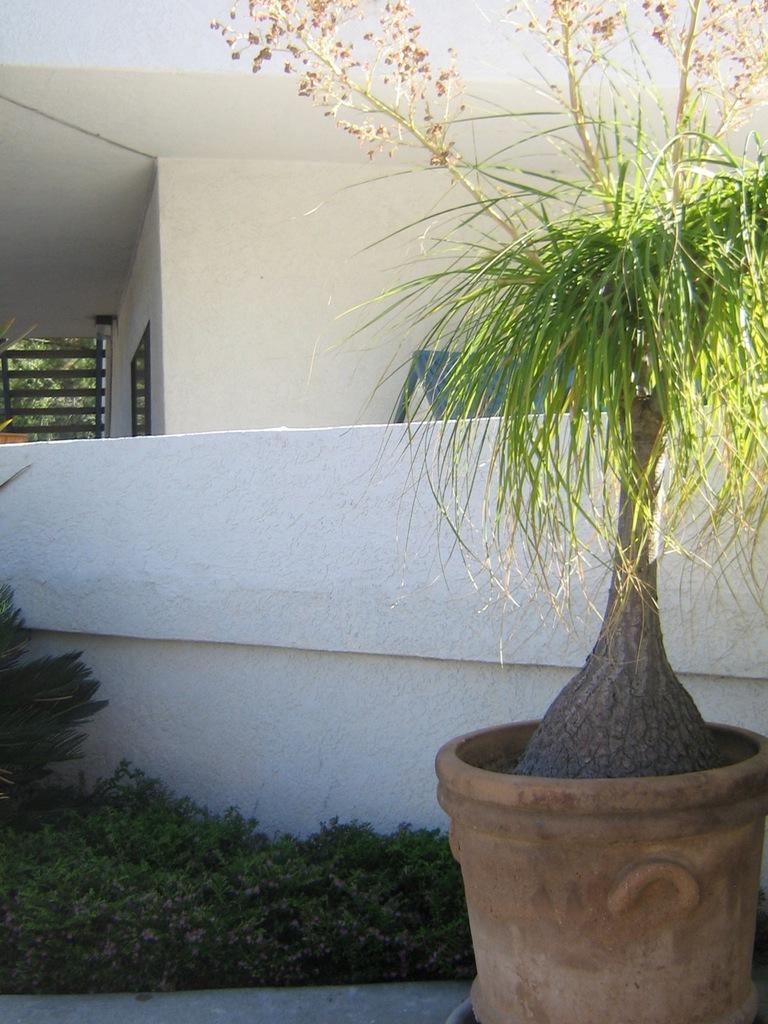In one or two sentences, can you explain what this image depicts? In this image on the right side we can see a plant in a pot and there are plants on the ground on left side at the wall. In the background we can see a house, trees and objects. 